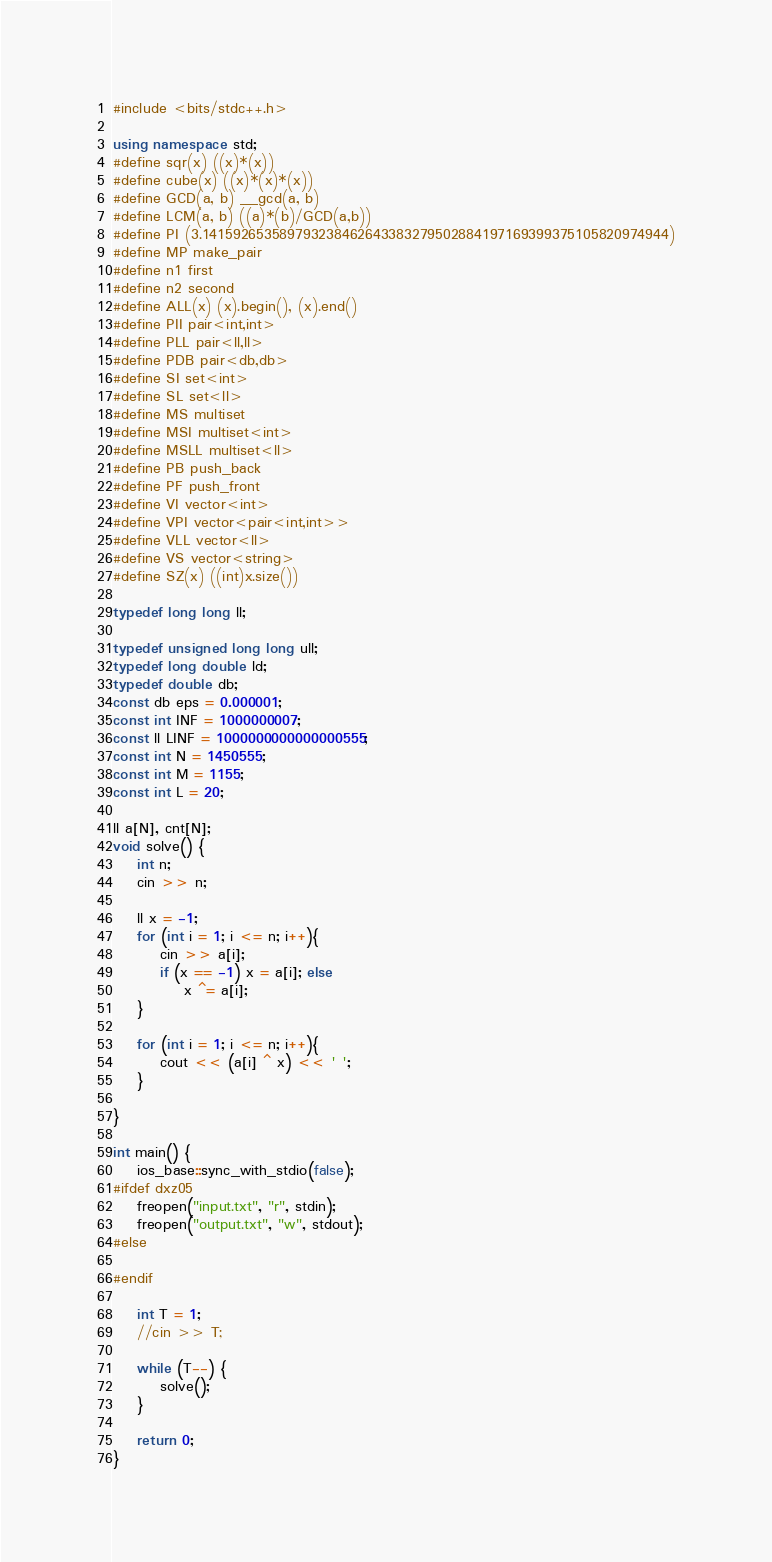Convert code to text. <code><loc_0><loc_0><loc_500><loc_500><_C++_>#include <bits/stdc++.h>

using namespace std;
#define sqr(x) ((x)*(x))
#define cube(x) ((x)*(x)*(x))
#define GCD(a, b) __gcd(a, b)
#define LCM(a, b) ((a)*(b)/GCD(a,b))
#define PI (3.141592653589793238462643383279502884197169399375105820974944)
#define MP make_pair
#define n1 first
#define n2 second
#define ALL(x) (x).begin(), (x).end()
#define PII pair<int,int>
#define PLL pair<ll,ll>
#define PDB pair<db,db>
#define SI set<int>
#define SL set<ll>
#define MS multiset
#define MSI multiset<int>
#define MSLL multiset<ll>
#define PB push_back
#define PF push_front
#define VI vector<int>
#define VPI vector<pair<int,int>>
#define VLL vector<ll>
#define VS vector<string>
#define SZ(x) ((int)x.size())

typedef long long ll;

typedef unsigned long long ull;
typedef long double ld;
typedef double db;
const db eps = 0.000001;
const int INF = 1000000007;
const ll LINF = 1000000000000000555;
const int N = 1450555;
const int M = 1155;
const int L = 20;

ll a[N], cnt[N];
void solve() {
    int n;
    cin >> n;

    ll x = -1;
    for (int i = 1; i <= n; i++){
        cin >> a[i];
        if (x == -1) x = a[i]; else
            x ^= a[i];
    }

    for (int i = 1; i <= n; i++){
        cout << (a[i] ^ x) << ' ';
    }

}

int main() {
    ios_base::sync_with_stdio(false);
#ifdef dxz05
    freopen("input.txt", "r", stdin);
    freopen("output.txt", "w", stdout);
#else

#endif

    int T = 1;
    //cin >> T;

    while (T--) {
        solve();
    }

    return 0;
}</code> 